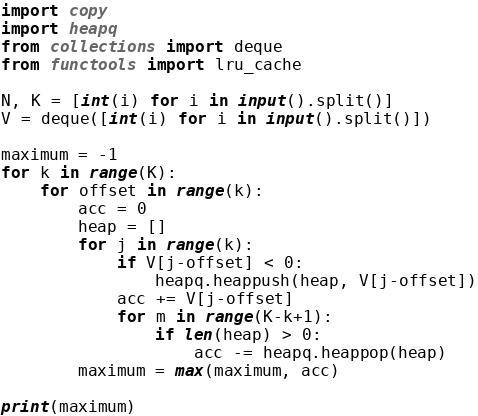Convert code to text. <code><loc_0><loc_0><loc_500><loc_500><_Python_>import copy
import heapq
from collections import deque
from functools import lru_cache

N, K = [int(i) for i in input().split()]
V = deque([int(i) for i in input().split()])

maximum = -1
for k in range(K):
    for offset in range(k):
        acc = 0
        heap = []
        for j in range(k):
            if V[j-offset] < 0:
                heapq.heappush(heap, V[j-offset])
            acc += V[j-offset]
            for m in range(K-k+1):
                if len(heap) > 0:
                    acc -= heapq.heappop(heap)
        maximum = max(maximum, acc)

print(maximum)
</code> 